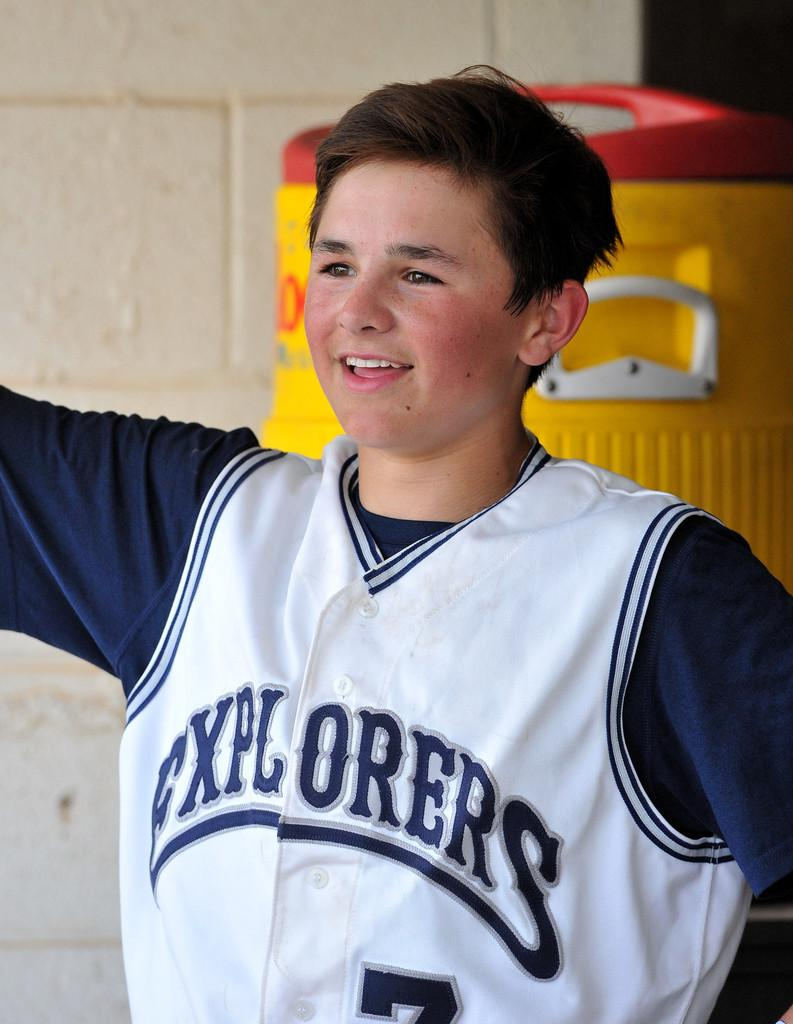What is the main subject of the image? There is a boy in the middle of the image. What is the boy's facial expression? The boy has a smiling face. What can be seen in the background of the image? There is a wall and an object in the background of the image. What type of veil is covering the boy's ear in the image? There is no veil or ear visible in the image; it features a boy with a smiling face in the middle of the image. What kind of machine is being operated by the boy in the image? There is no machine present in the image; it only shows a boy with a smiling face in the middle of the image. 